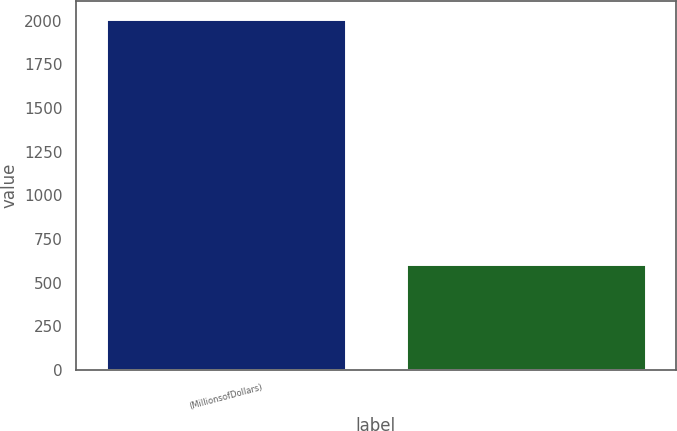Convert chart. <chart><loc_0><loc_0><loc_500><loc_500><bar_chart><fcel>(MillionsofDollars)<fcel>Unnamed: 1<nl><fcel>2012<fcel>603.74<nl></chart> 